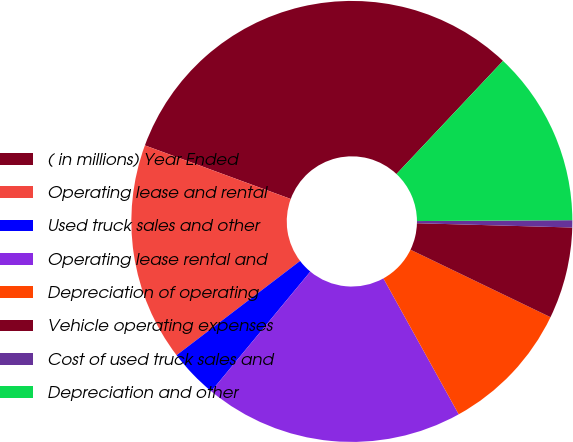<chart> <loc_0><loc_0><loc_500><loc_500><pie_chart><fcel>( in millions) Year Ended<fcel>Operating lease and rental<fcel>Used truck sales and other<fcel>Operating lease rental and<fcel>Depreciation of operating<fcel>Vehicle operating expenses<fcel>Cost of used truck sales and<fcel>Depreciation and other<nl><fcel>31.42%<fcel>15.98%<fcel>3.62%<fcel>19.06%<fcel>9.8%<fcel>6.71%<fcel>0.53%<fcel>12.89%<nl></chart> 